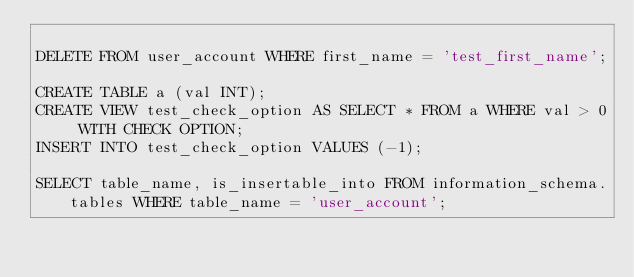Convert code to text. <code><loc_0><loc_0><loc_500><loc_500><_SQL_>
DELETE FROM user_account WHERE first_name = 'test_first_name';

CREATE TABLE a (val INT);
CREATE VIEW test_check_option AS SELECT * FROM a WHERE val > 0 WITH CHECK OPTION;
INSERT INTO test_check_option VALUES (-1);

SELECT table_name, is_insertable_into FROM information_schema.tables WHERE table_name = 'user_account';

</code> 